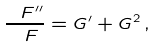Convert formula to latex. <formula><loc_0><loc_0><loc_500><loc_500>\frac { \ F ^ { \prime \prime } } { \ F } = G ^ { \prime } + G ^ { 2 } \, ,</formula> 